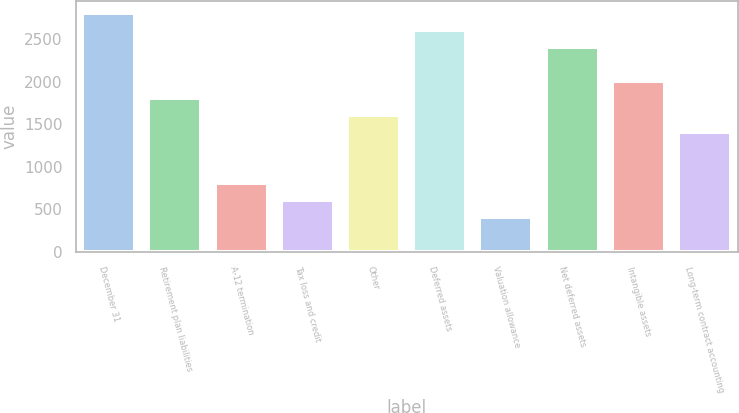Convert chart. <chart><loc_0><loc_0><loc_500><loc_500><bar_chart><fcel>December 31<fcel>Retirement plan liabilities<fcel>A-12 termination<fcel>Tax loss and credit<fcel>Other<fcel>Deferred assets<fcel>Valuation allowance<fcel>Net deferred assets<fcel>Intangible assets<fcel>Long-term contract accounting<nl><fcel>2808.4<fcel>1807.9<fcel>807.4<fcel>607.3<fcel>1607.8<fcel>2608.3<fcel>407.2<fcel>2408.2<fcel>2008<fcel>1407.7<nl></chart> 